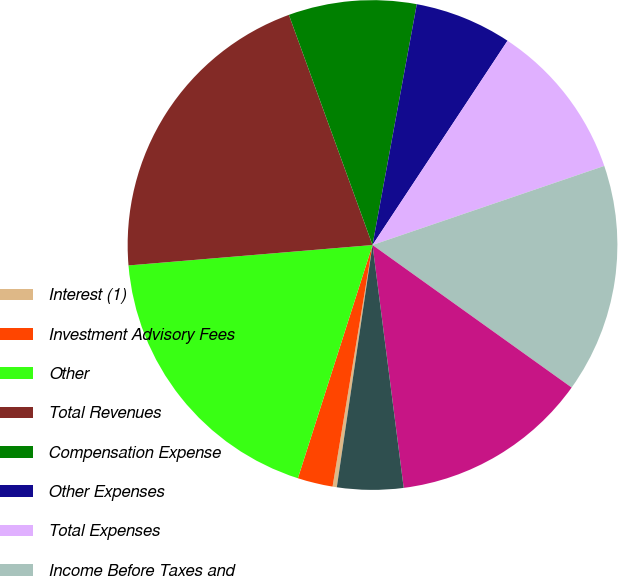<chart> <loc_0><loc_0><loc_500><loc_500><pie_chart><fcel>Interest (1)<fcel>Investment Advisory Fees<fcel>Other<fcel>Total Revenues<fcel>Compensation Expense<fcel>Other Expenses<fcel>Total Expenses<fcel>Income Before Taxes and<fcel>Noncontrolling Interests<fcel>Pre-tax Income Excluding<nl><fcel>0.28%<fcel>2.32%<fcel>18.74%<fcel>20.78%<fcel>8.44%<fcel>6.4%<fcel>10.47%<fcel>15.12%<fcel>13.08%<fcel>4.36%<nl></chart> 